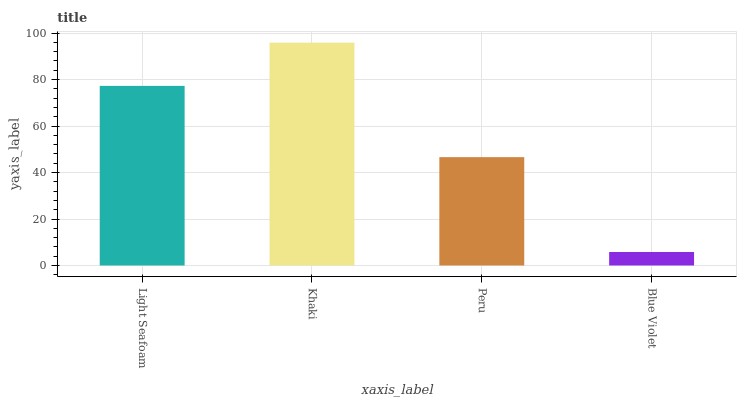Is Blue Violet the minimum?
Answer yes or no. Yes. Is Khaki the maximum?
Answer yes or no. Yes. Is Peru the minimum?
Answer yes or no. No. Is Peru the maximum?
Answer yes or no. No. Is Khaki greater than Peru?
Answer yes or no. Yes. Is Peru less than Khaki?
Answer yes or no. Yes. Is Peru greater than Khaki?
Answer yes or no. No. Is Khaki less than Peru?
Answer yes or no. No. Is Light Seafoam the high median?
Answer yes or no. Yes. Is Peru the low median?
Answer yes or no. Yes. Is Peru the high median?
Answer yes or no. No. Is Khaki the low median?
Answer yes or no. No. 